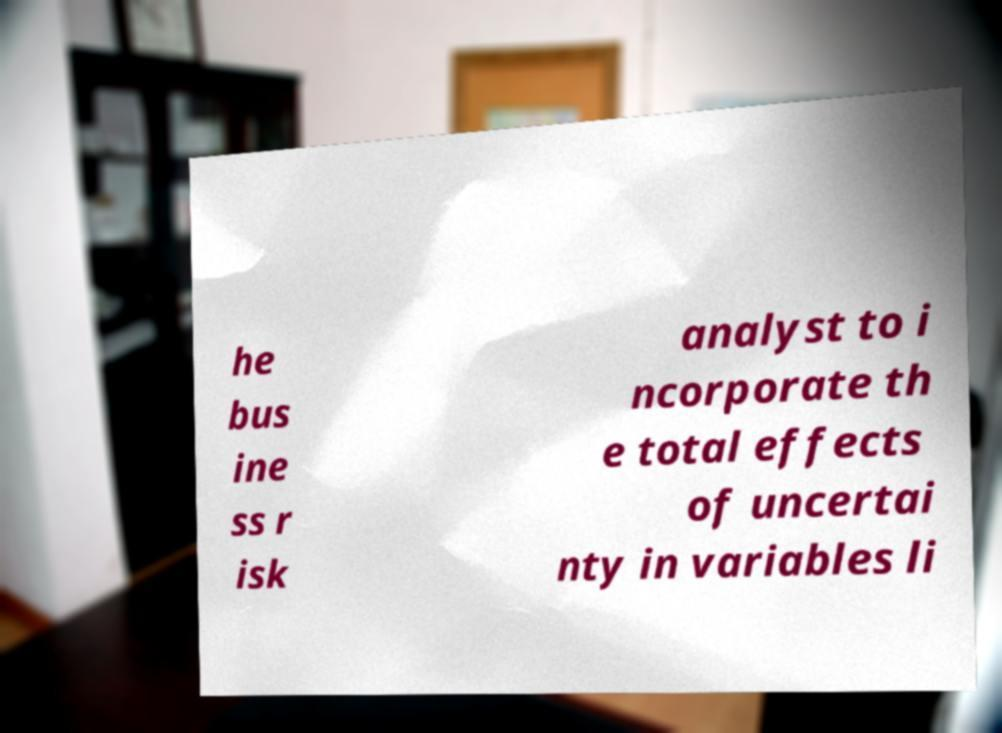Could you assist in decoding the text presented in this image and type it out clearly? he bus ine ss r isk analyst to i ncorporate th e total effects of uncertai nty in variables li 